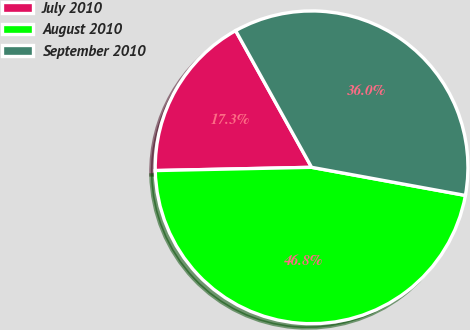<chart> <loc_0><loc_0><loc_500><loc_500><pie_chart><fcel>July 2010<fcel>August 2010<fcel>September 2010<nl><fcel>17.26%<fcel>46.79%<fcel>35.95%<nl></chart> 